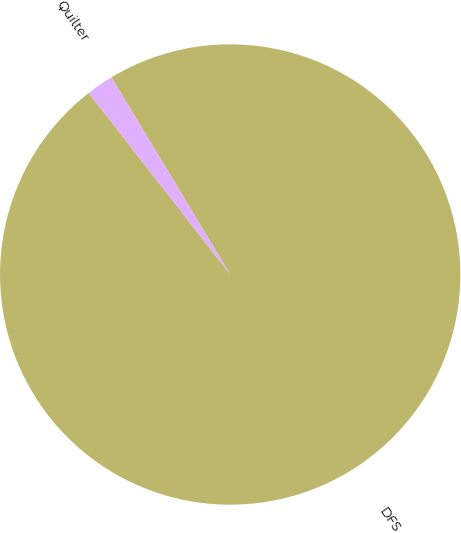<chart> <loc_0><loc_0><loc_500><loc_500><pie_chart><fcel>DFS<fcel>Quilter<nl><fcel>98.09%<fcel>1.91%<nl></chart> 